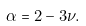<formula> <loc_0><loc_0><loc_500><loc_500>\alpha = 2 - 3 \nu .</formula> 